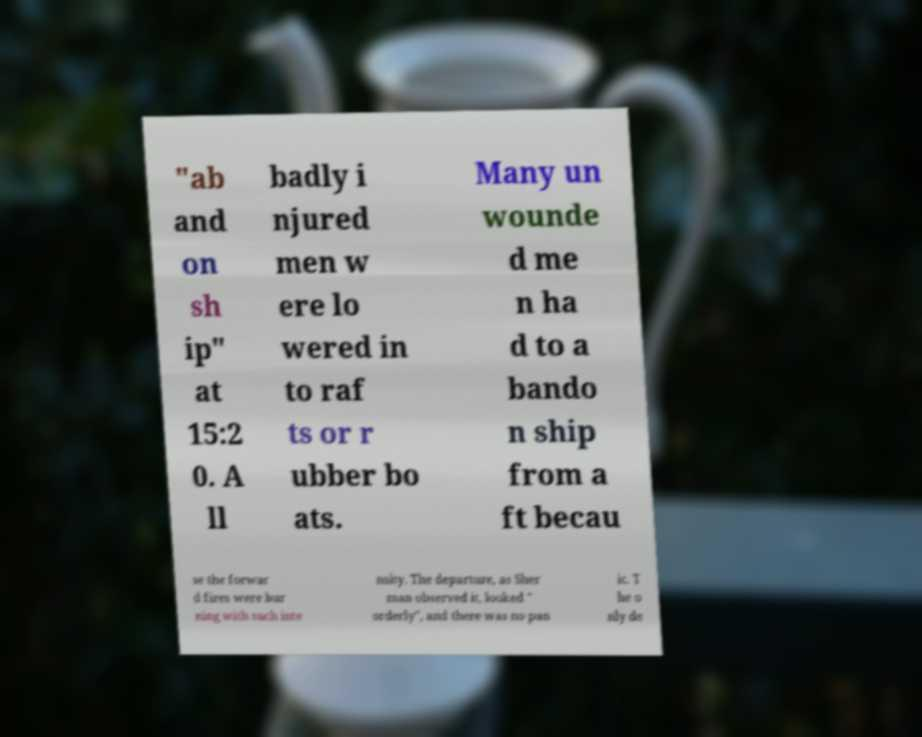Please identify and transcribe the text found in this image. "ab and on sh ip" at 15:2 0. A ll badly i njured men w ere lo wered in to raf ts or r ubber bo ats. Many un wounde d me n ha d to a bando n ship from a ft becau se the forwar d fires were bur ning with such inte nsity. The departure, as Sher man observed it, looked " orderly", and there was no pan ic. T he o nly de 